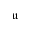Convert formula to latex. <formula><loc_0><loc_0><loc_500><loc_500>\mathfrak u</formula> 